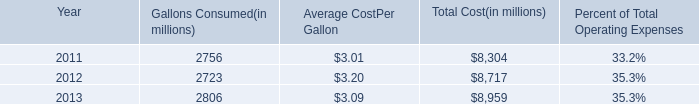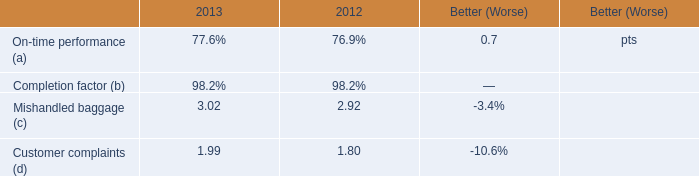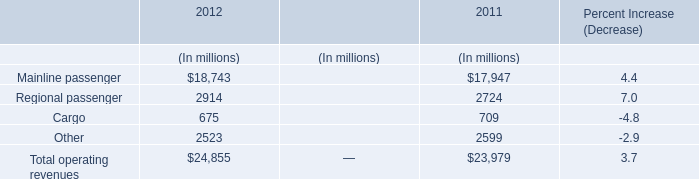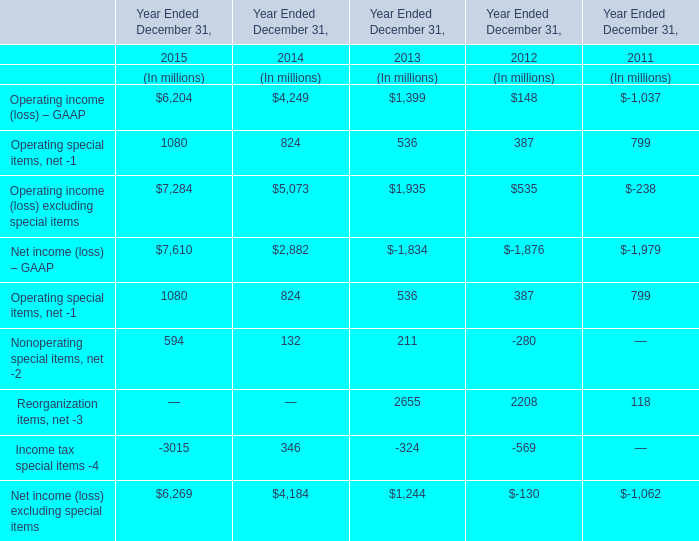What's the growth rate of Operating income (loss) – GAAP in 2015? 
Computations: ((6204 - 4249) / 4249)
Answer: 0.46011. 